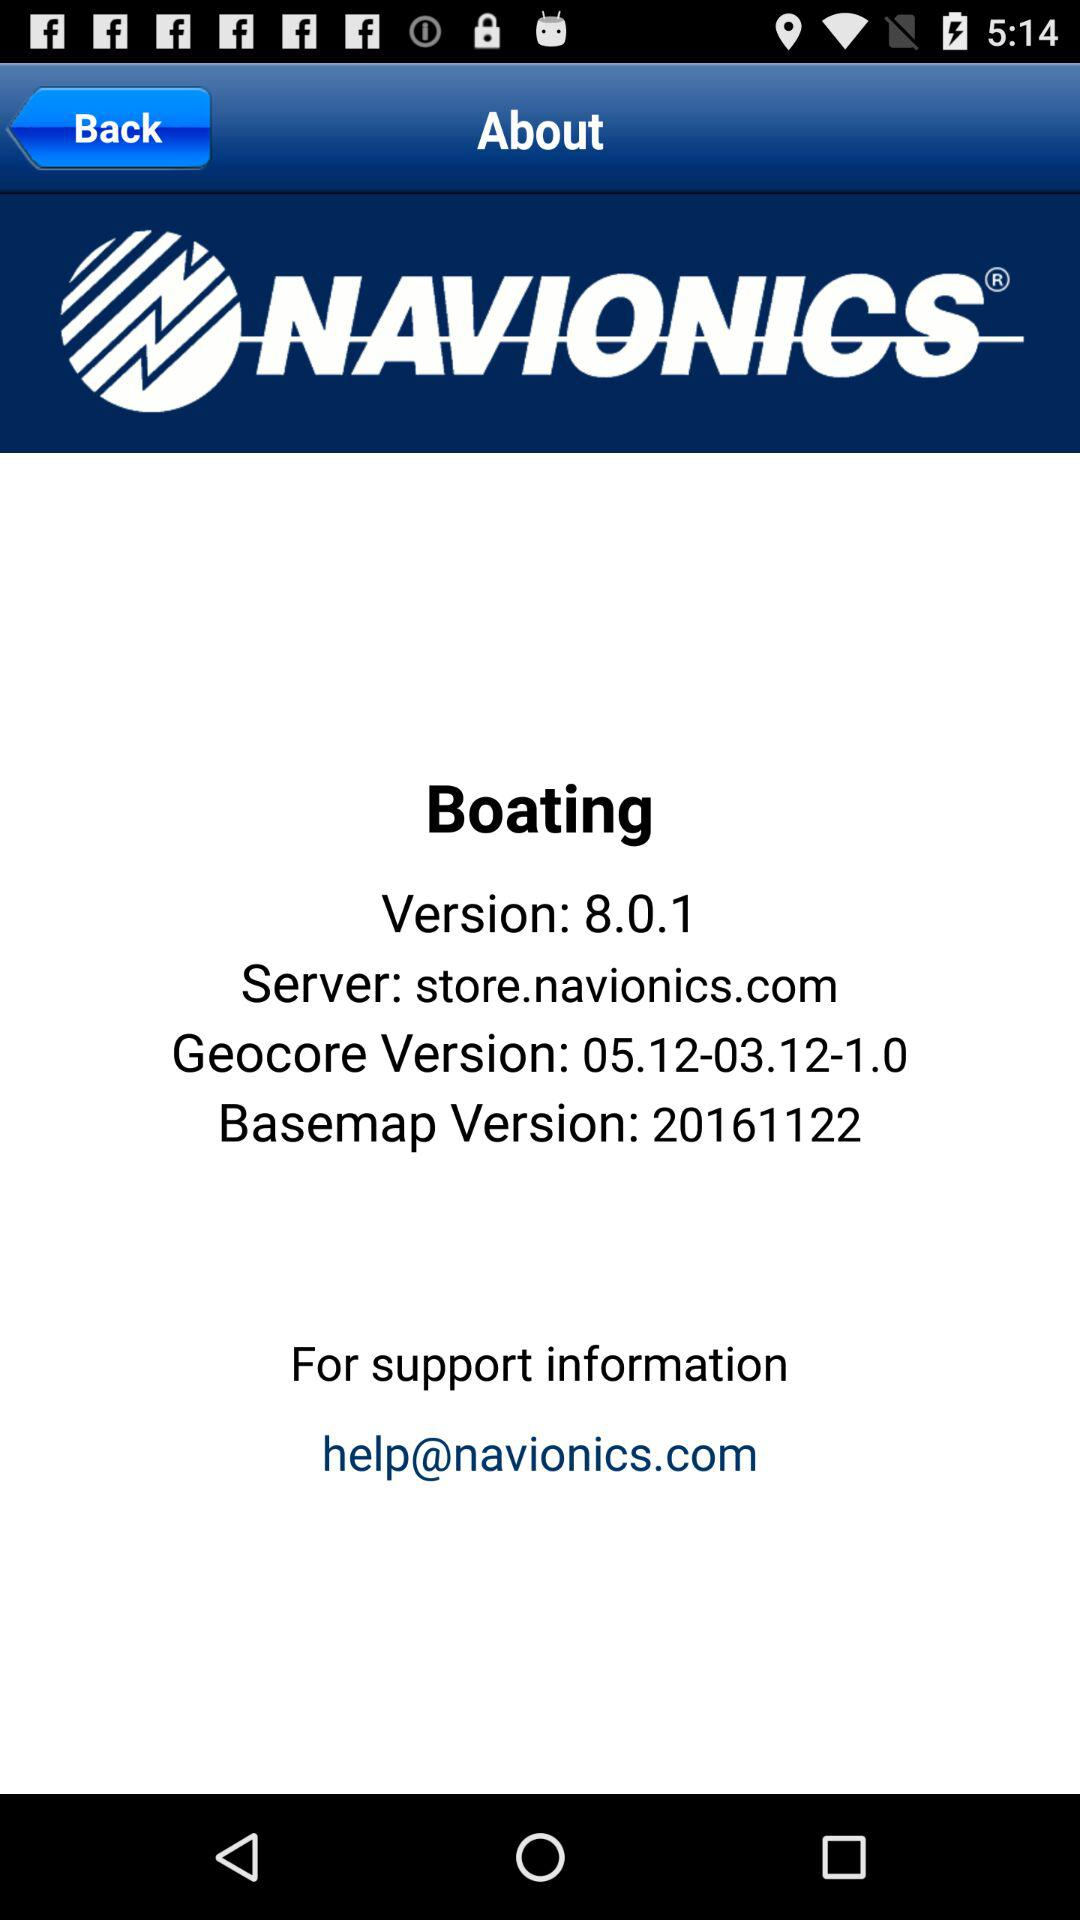What's the Geocore Version? The version is 05.12-03.12-1.0. 